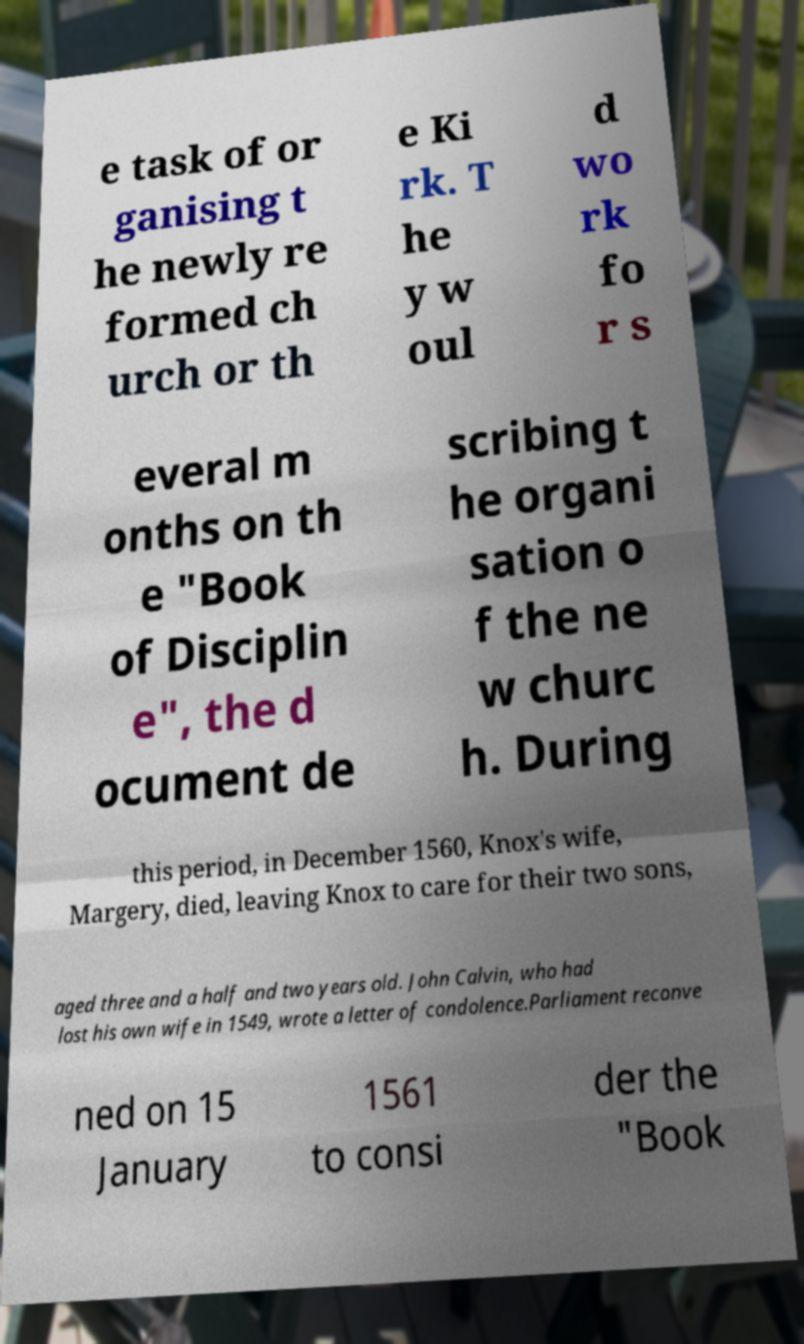There's text embedded in this image that I need extracted. Can you transcribe it verbatim? e task of or ganising t he newly re formed ch urch or th e Ki rk. T he y w oul d wo rk fo r s everal m onths on th e "Book of Disciplin e", the d ocument de scribing t he organi sation o f the ne w churc h. During this period, in December 1560, Knox's wife, Margery, died, leaving Knox to care for their two sons, aged three and a half and two years old. John Calvin, who had lost his own wife in 1549, wrote a letter of condolence.Parliament reconve ned on 15 January 1561 to consi der the "Book 